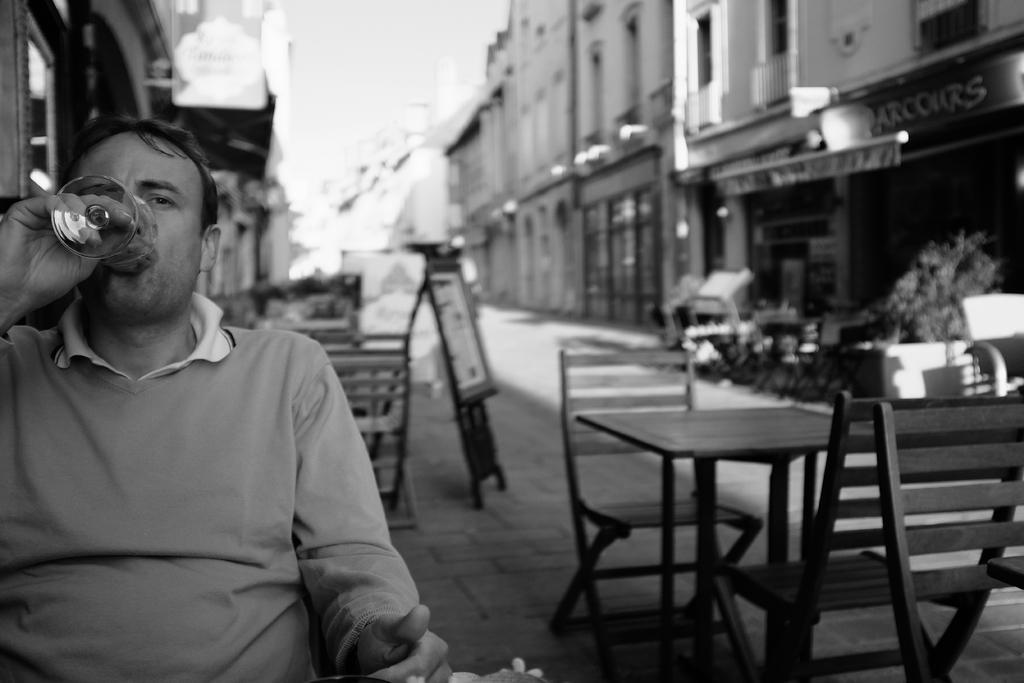Please provide a concise description of this image. A man is sitting and drinking something holding a glass in his hand. There is a table and there are some chairs. And we can see a board on the path. And there some building to the right side corner. 